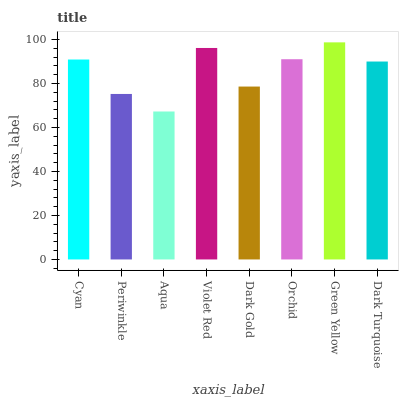Is Aqua the minimum?
Answer yes or no. Yes. Is Green Yellow the maximum?
Answer yes or no. Yes. Is Periwinkle the minimum?
Answer yes or no. No. Is Periwinkle the maximum?
Answer yes or no. No. Is Cyan greater than Periwinkle?
Answer yes or no. Yes. Is Periwinkle less than Cyan?
Answer yes or no. Yes. Is Periwinkle greater than Cyan?
Answer yes or no. No. Is Cyan less than Periwinkle?
Answer yes or no. No. Is Cyan the high median?
Answer yes or no. Yes. Is Dark Turquoise the low median?
Answer yes or no. Yes. Is Periwinkle the high median?
Answer yes or no. No. Is Violet Red the low median?
Answer yes or no. No. 